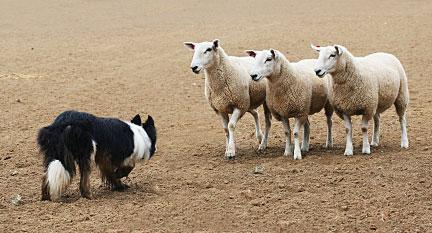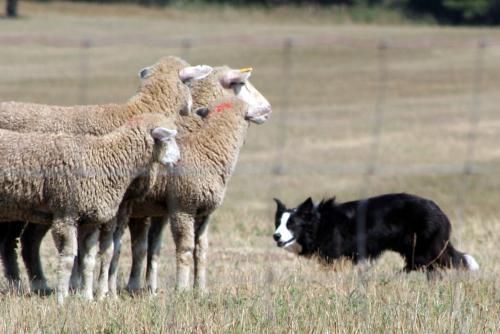The first image is the image on the left, the second image is the image on the right. Assess this claim about the two images: "The right image contains exactly three sheep.". Correct or not? Answer yes or no. Yes. The first image is the image on the left, the second image is the image on the right. For the images shown, is this caption "There are less than three animals in one of the images." true? Answer yes or no. No. 